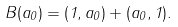<formula> <loc_0><loc_0><loc_500><loc_500>B ( a _ { 0 } ) = ( 1 , a _ { 0 } ) + ( a _ { 0 } , 1 ) .</formula> 